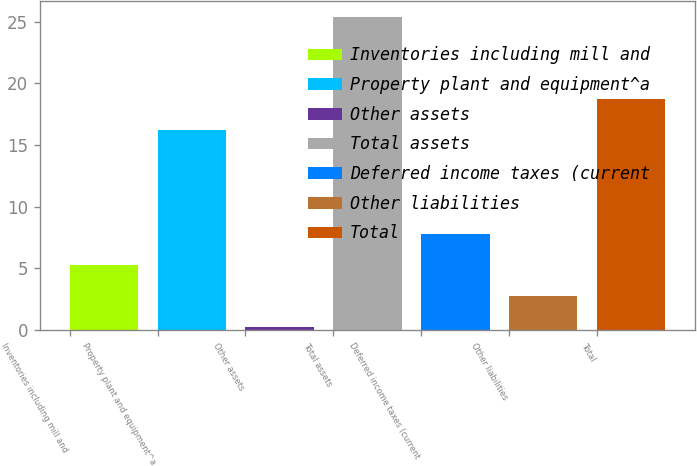Convert chart. <chart><loc_0><loc_0><loc_500><loc_500><bar_chart><fcel>Inventories including mill and<fcel>Property plant and equipment^a<fcel>Other assets<fcel>Total assets<fcel>Deferred income taxes (current<fcel>Other liabilities<fcel>Total<nl><fcel>5.24<fcel>16.2<fcel>0.2<fcel>25.4<fcel>7.76<fcel>2.72<fcel>18.72<nl></chart> 